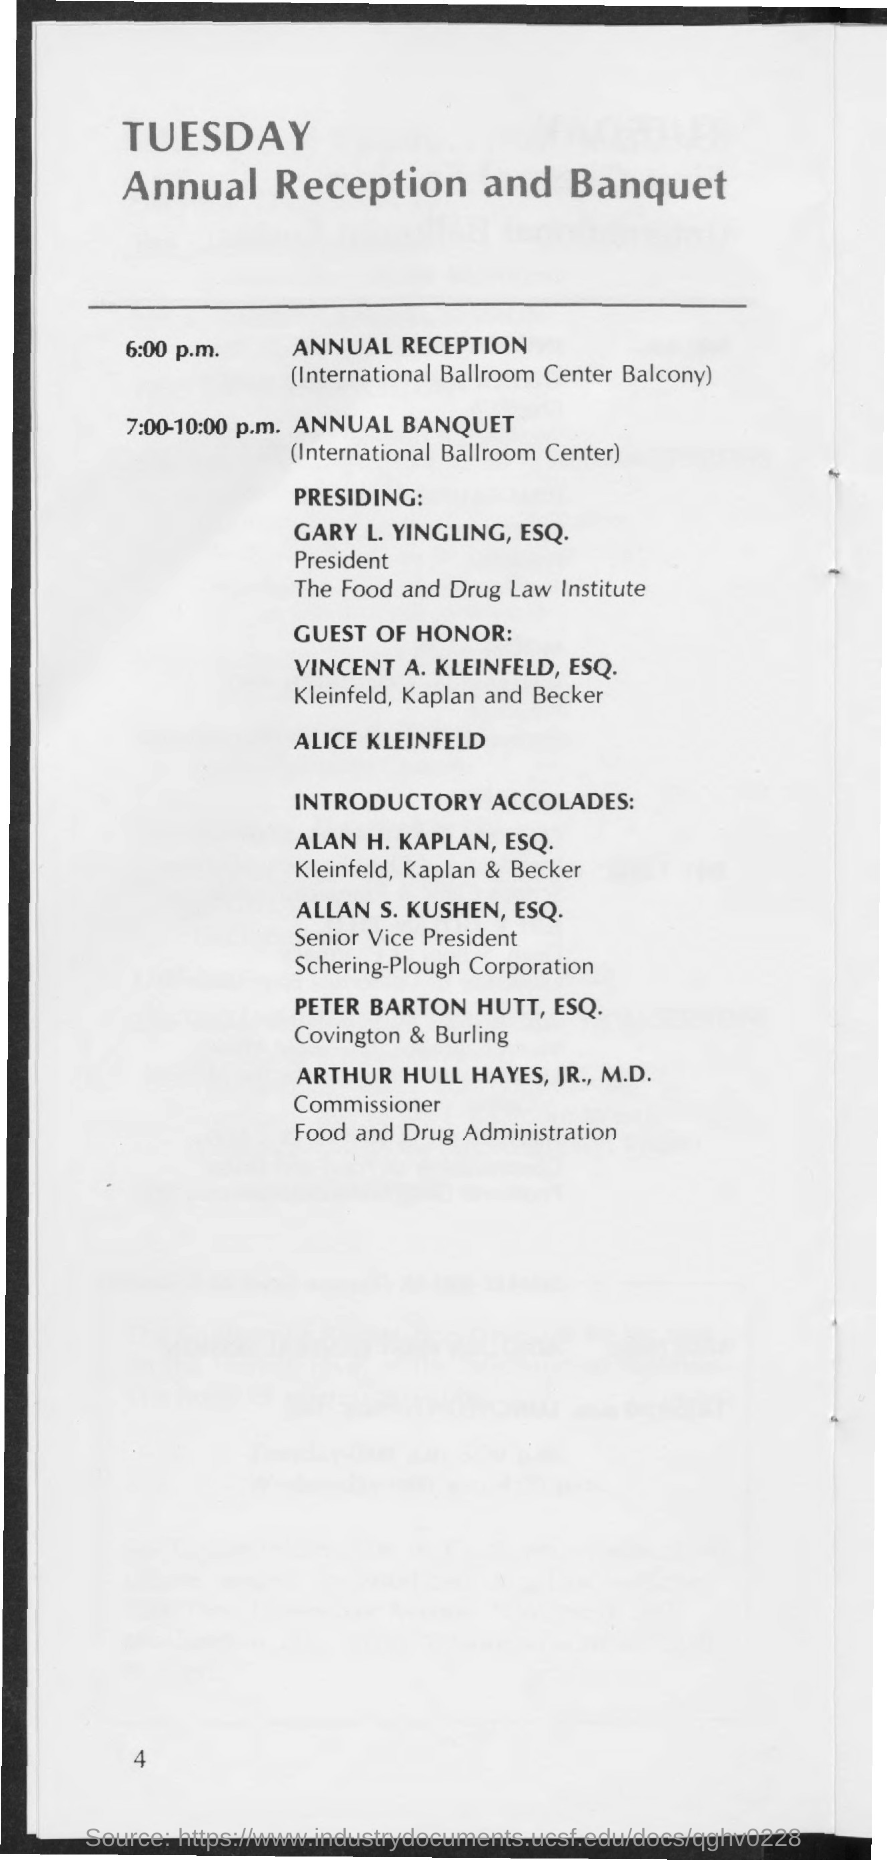What time is ANNUAL RECEPTION scheduled?
Provide a succinct answer. 6:00 p.m. Where is ANNUAL RECEPTION scheduled?
Your answer should be very brief. International Ballroom Center Balcony. What time is ANNUAL BANQUET Scheduled?
Give a very brief answer. 7:00-10:00 p.m. Where is ANNUAL BANQUET Scheduled?
Offer a very short reply. International Ballroom Center. Who is presiding the event?
Make the answer very short. GARY L. YINGLING, ESQ. 